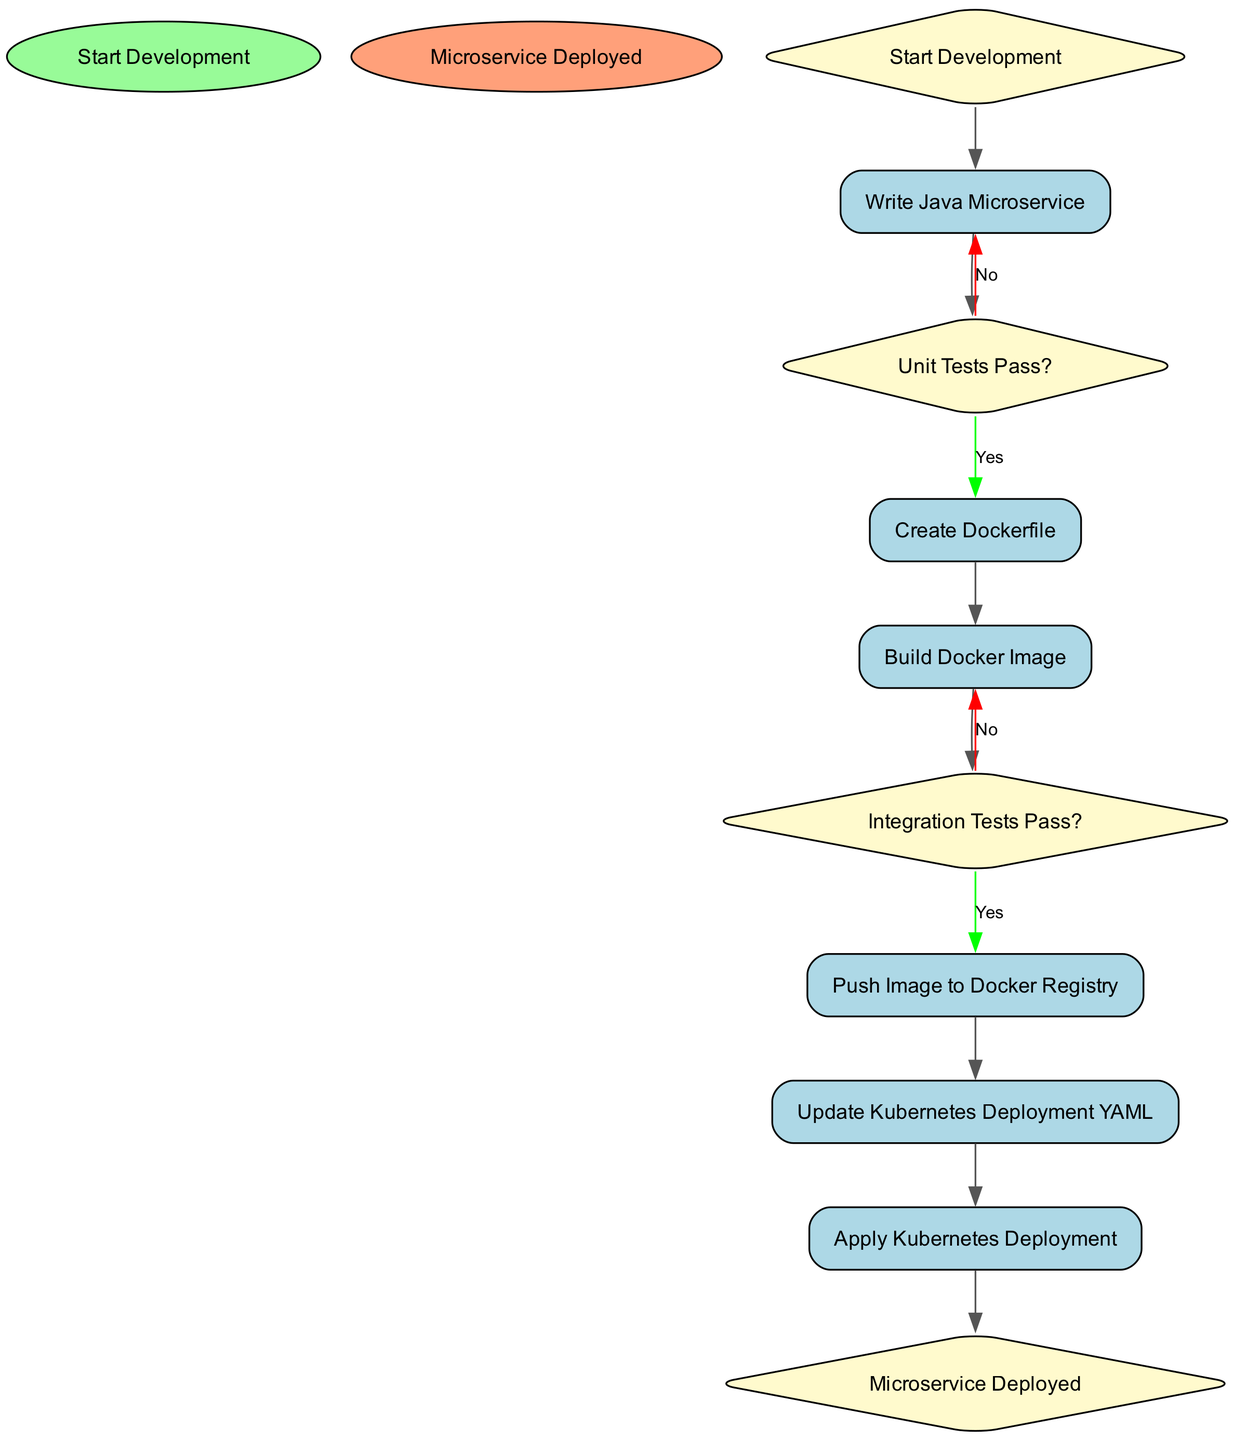What is the first activity in the diagram? The first activity, as indicated by the starting node, is "Write Java Microservice." This is the first step after the "Start Development" node.
Answer: Write Java Microservice How many activities are present in the diagram? There are six activities listed in the diagram: "Write Java Microservice," "Create Dockerfile," "Build Docker Image," "Push Image to Docker Registry," "Update Kubernetes Deployment YAML," and "Apply Kubernetes Deployment." Counting these gives a total of six activities.
Answer: 6 What happens if the unit tests fail? If the unit tests do not pass, the flow goes back to "Write Java Microservice." This is the outcome of the decision node that checks if the unit tests pass.
Answer: Write Java Microservice What is the final node in the deployment workflow? The final node in the deployment workflow is "Microservice Deployed." This indicates the completion of the whole process after all necessary activities have been executed.
Answer: Microservice Deployed What decision follows the "Build Docker Image" activity? The decision that follows the "Build Docker Image" activity is "Integration Tests Pass?" This is where the next step hinges on whether the integration tests are successful or not.
Answer: Integration Tests Pass? What is the relationship between "Push Image to Docker Registry" and "Update Kubernetes Deployment YAML"? The relationship is sequential; after "Push Image to Docker Registry," the next activity is "Update Kubernetes Deployment YAML." This indicates that the pushing of the image must occur before updating the deployment YAML.
Answer: Update Kubernetes Deployment YAML If the integration tests do not pass, what is the next activity? If the integration tests do not pass, the next activity is "Build Docker Image." This means that failing the integration tests requires going back to build the image again.
Answer: Build Docker Image Which node represents a decision point in the flow? The nodes representing decision points in the flow are "Unit Tests Pass?" and "Integration Tests Pass?" Both of these nodes ask questions that determine the next step in the workflow.
Answer: Unit Tests Pass? and Integration Tests Pass? 